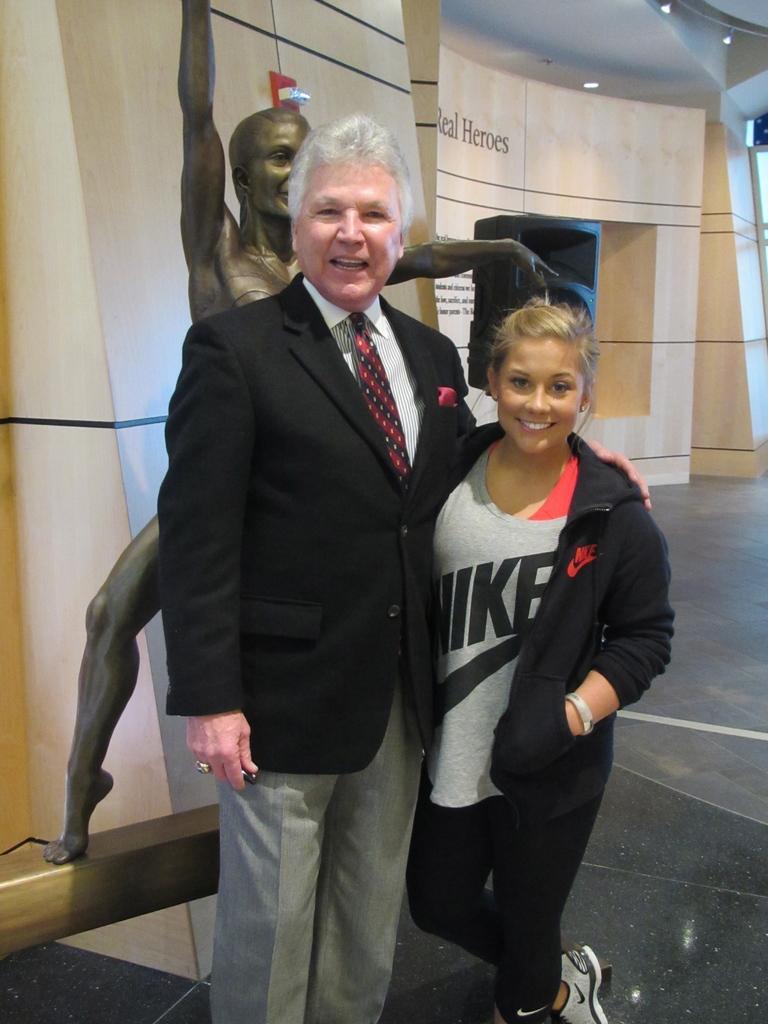In one or two sentences, can you explain what this image depicts? In this image in front there are two people wearing a smile on their faces. Behind them there is a statue. In the background of the image there is a wall. On top of the image there are lights. At the bottom of the image there is a floor. 